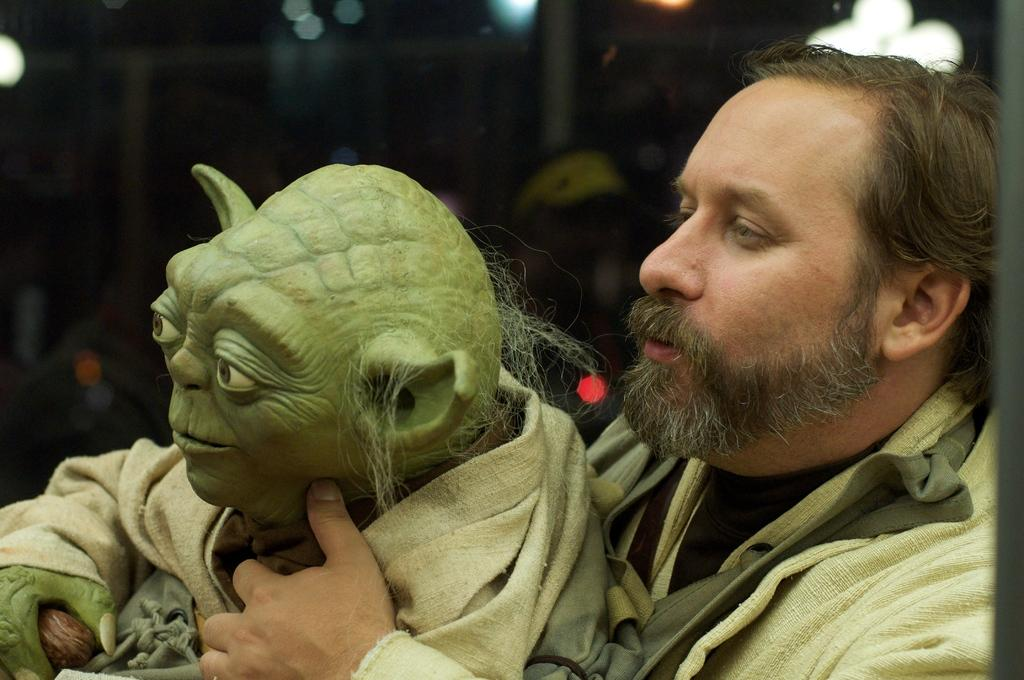Who or what is present on the right side of the image? There is a person on the right side of the image. What is the person doing in the image? The person is holding a creature in his hands. Can you describe the background of the image? The background of the image is blurred, and lights are visible in it. What type of basketball is the person playing with in the image? There is no basketball present in the image; the person is holding a creature in his hands. What kind of spark can be seen coming from the creature in the image? There is no spark visible in the image; the creature is simply being held by the person. 